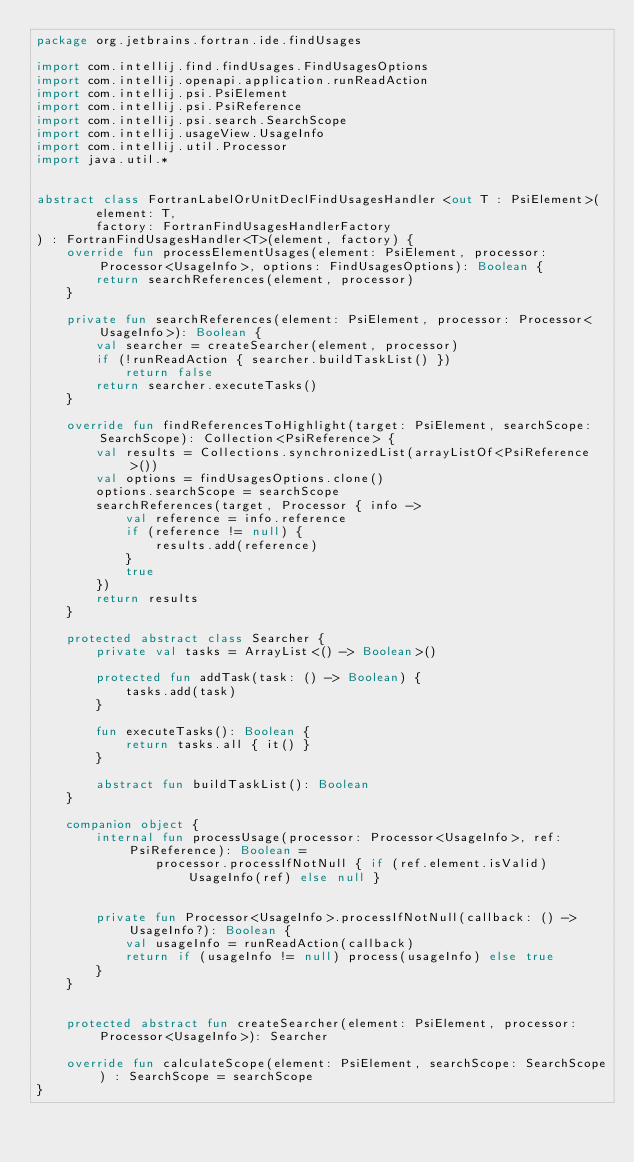<code> <loc_0><loc_0><loc_500><loc_500><_Kotlin_>package org.jetbrains.fortran.ide.findUsages

import com.intellij.find.findUsages.FindUsagesOptions
import com.intellij.openapi.application.runReadAction
import com.intellij.psi.PsiElement
import com.intellij.psi.PsiReference
import com.intellij.psi.search.SearchScope
import com.intellij.usageView.UsageInfo
import com.intellij.util.Processor
import java.util.*


abstract class FortranLabelOrUnitDeclFindUsagesHandler <out T : PsiElement>(
        element: T,
        factory: FortranFindUsagesHandlerFactory
) : FortranFindUsagesHandler<T>(element, factory) {
    override fun processElementUsages(element: PsiElement, processor: Processor<UsageInfo>, options: FindUsagesOptions): Boolean {
        return searchReferences(element, processor)
    }

    private fun searchReferences(element: PsiElement, processor: Processor<UsageInfo>): Boolean {
        val searcher = createSearcher(element, processor)
        if (!runReadAction { searcher.buildTaskList() })
            return false
        return searcher.executeTasks()
    }

    override fun findReferencesToHighlight(target: PsiElement, searchScope: SearchScope): Collection<PsiReference> {
        val results = Collections.synchronizedList(arrayListOf<PsiReference>())
        val options = findUsagesOptions.clone()
        options.searchScope = searchScope
        searchReferences(target, Processor { info ->
            val reference = info.reference
            if (reference != null) {
                results.add(reference)
            }
            true
        })
        return results
    }

    protected abstract class Searcher {
        private val tasks = ArrayList<() -> Boolean>()

        protected fun addTask(task: () -> Boolean) {
            tasks.add(task)
        }

        fun executeTasks(): Boolean {
            return tasks.all { it() }
        }

        abstract fun buildTaskList(): Boolean
    }

    companion object {
        internal fun processUsage(processor: Processor<UsageInfo>, ref: PsiReference): Boolean =
                processor.processIfNotNull { if (ref.element.isValid) UsageInfo(ref) else null }


        private fun Processor<UsageInfo>.processIfNotNull(callback: () -> UsageInfo?): Boolean {
            val usageInfo = runReadAction(callback)
            return if (usageInfo != null) process(usageInfo) else true
        }
    }


    protected abstract fun createSearcher(element: PsiElement, processor: Processor<UsageInfo>): Searcher

    override fun calculateScope(element: PsiElement, searchScope: SearchScope) : SearchScope = searchScope
}</code> 